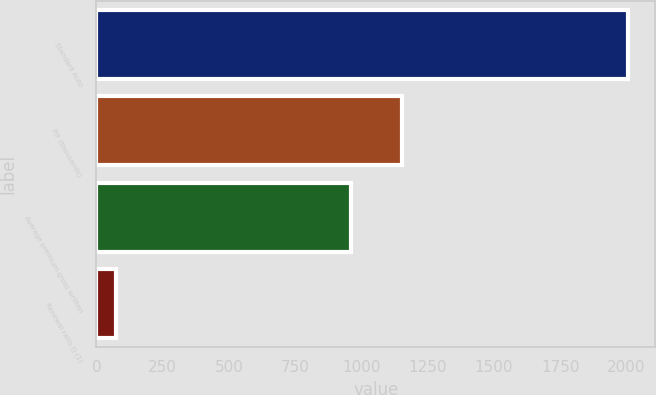Convert chart. <chart><loc_0><loc_0><loc_500><loc_500><bar_chart><fcel>Standard Auto<fcel>PIF (thousands)<fcel>Average premium-gross written<fcel>Renewal ratio () (1)<nl><fcel>2008<fcel>1154.41<fcel>961<fcel>73.9<nl></chart> 